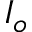Convert formula to latex. <formula><loc_0><loc_0><loc_500><loc_500>I _ { o }</formula> 